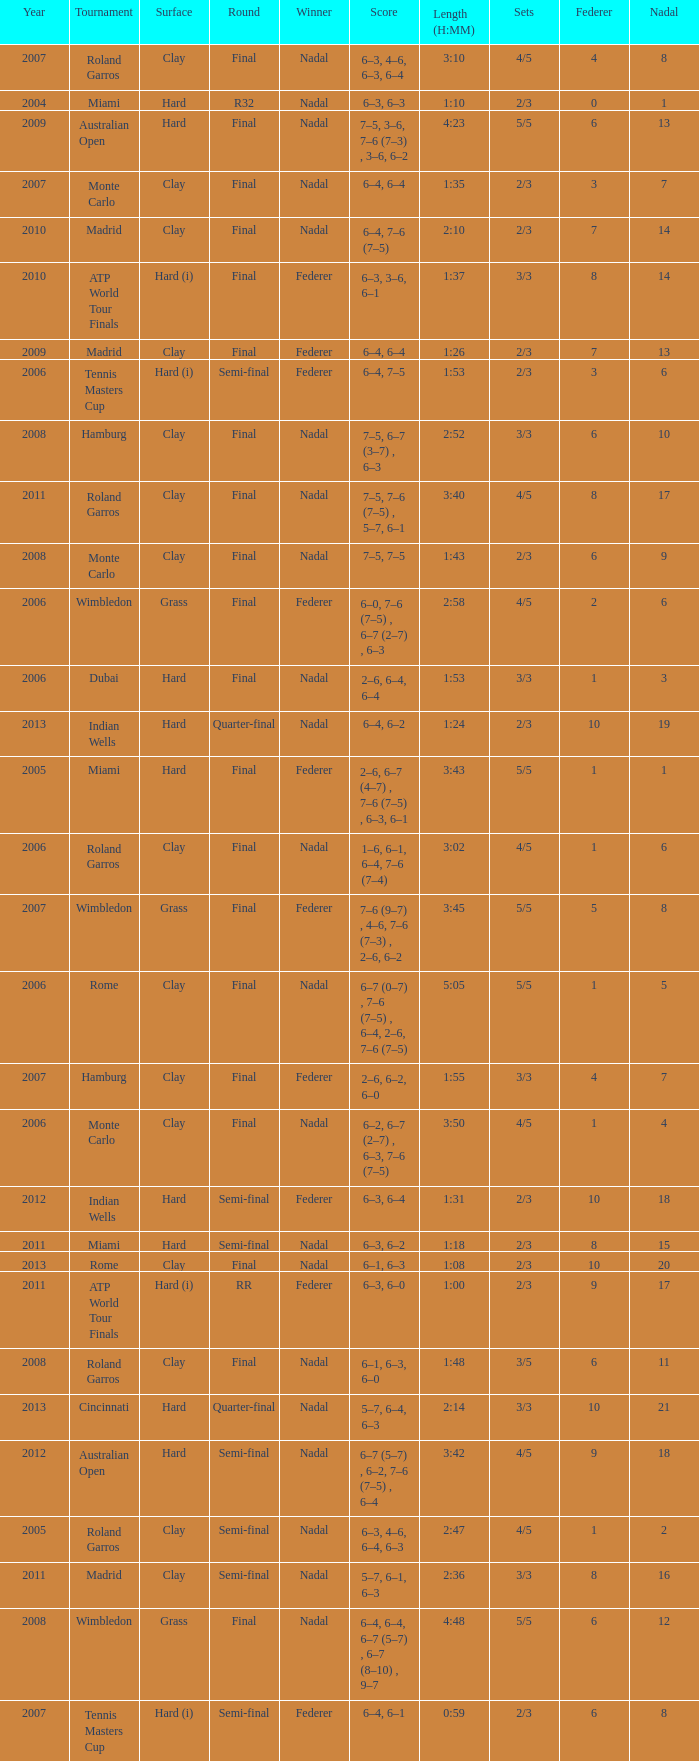What were the sets when Federer had 6 and a nadal of 13? 5/5. 